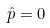<formula> <loc_0><loc_0><loc_500><loc_500>\hat { p } = 0</formula> 